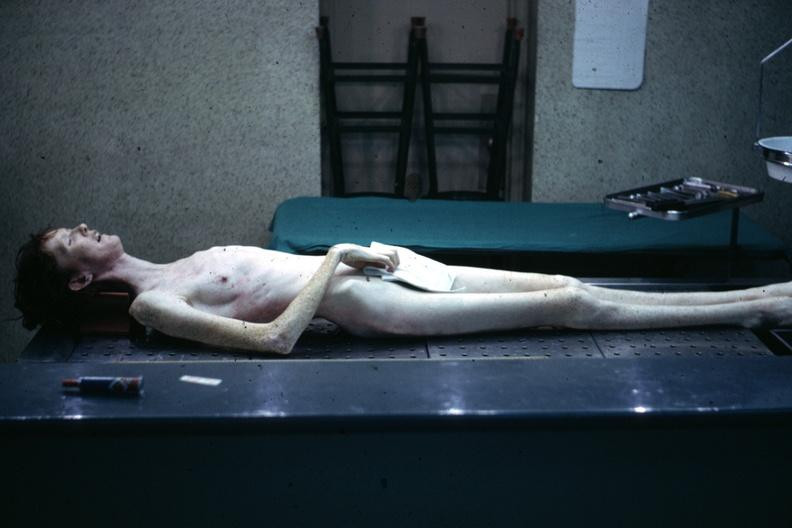s newborn cord around neck present?
Answer the question using a single word or phrase. No 